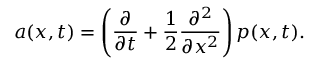Convert formula to latex. <formula><loc_0><loc_0><loc_500><loc_500>a ( x , t ) = \left ( { \frac { \partial } { \partial t } } + { \frac { 1 } { 2 } } { \frac { \partial ^ { 2 } } { \partial x ^ { 2 } } } \right ) p ( x , t ) .</formula> 